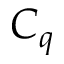<formula> <loc_0><loc_0><loc_500><loc_500>C _ { q }</formula> 